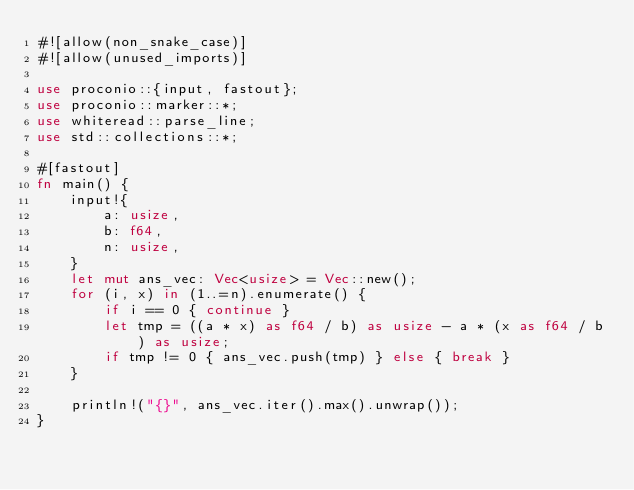Convert code to text. <code><loc_0><loc_0><loc_500><loc_500><_Rust_>#![allow(non_snake_case)]
#![allow(unused_imports)]
 
use proconio::{input, fastout};
use proconio::marker::*;
use whiteread::parse_line;
use std::collections::*;

#[fastout]
fn main() {
    input!{
        a: usize,
        b: f64,
        n: usize,
    }
    let mut ans_vec: Vec<usize> = Vec::new();
    for (i, x) in (1..=n).enumerate() {
        if i == 0 { continue }
        let tmp = ((a * x) as f64 / b) as usize - a * (x as f64 / b) as usize;
        if tmp != 0 { ans_vec.push(tmp) } else { break }
    }

    println!("{}", ans_vec.iter().max().unwrap());
}
</code> 